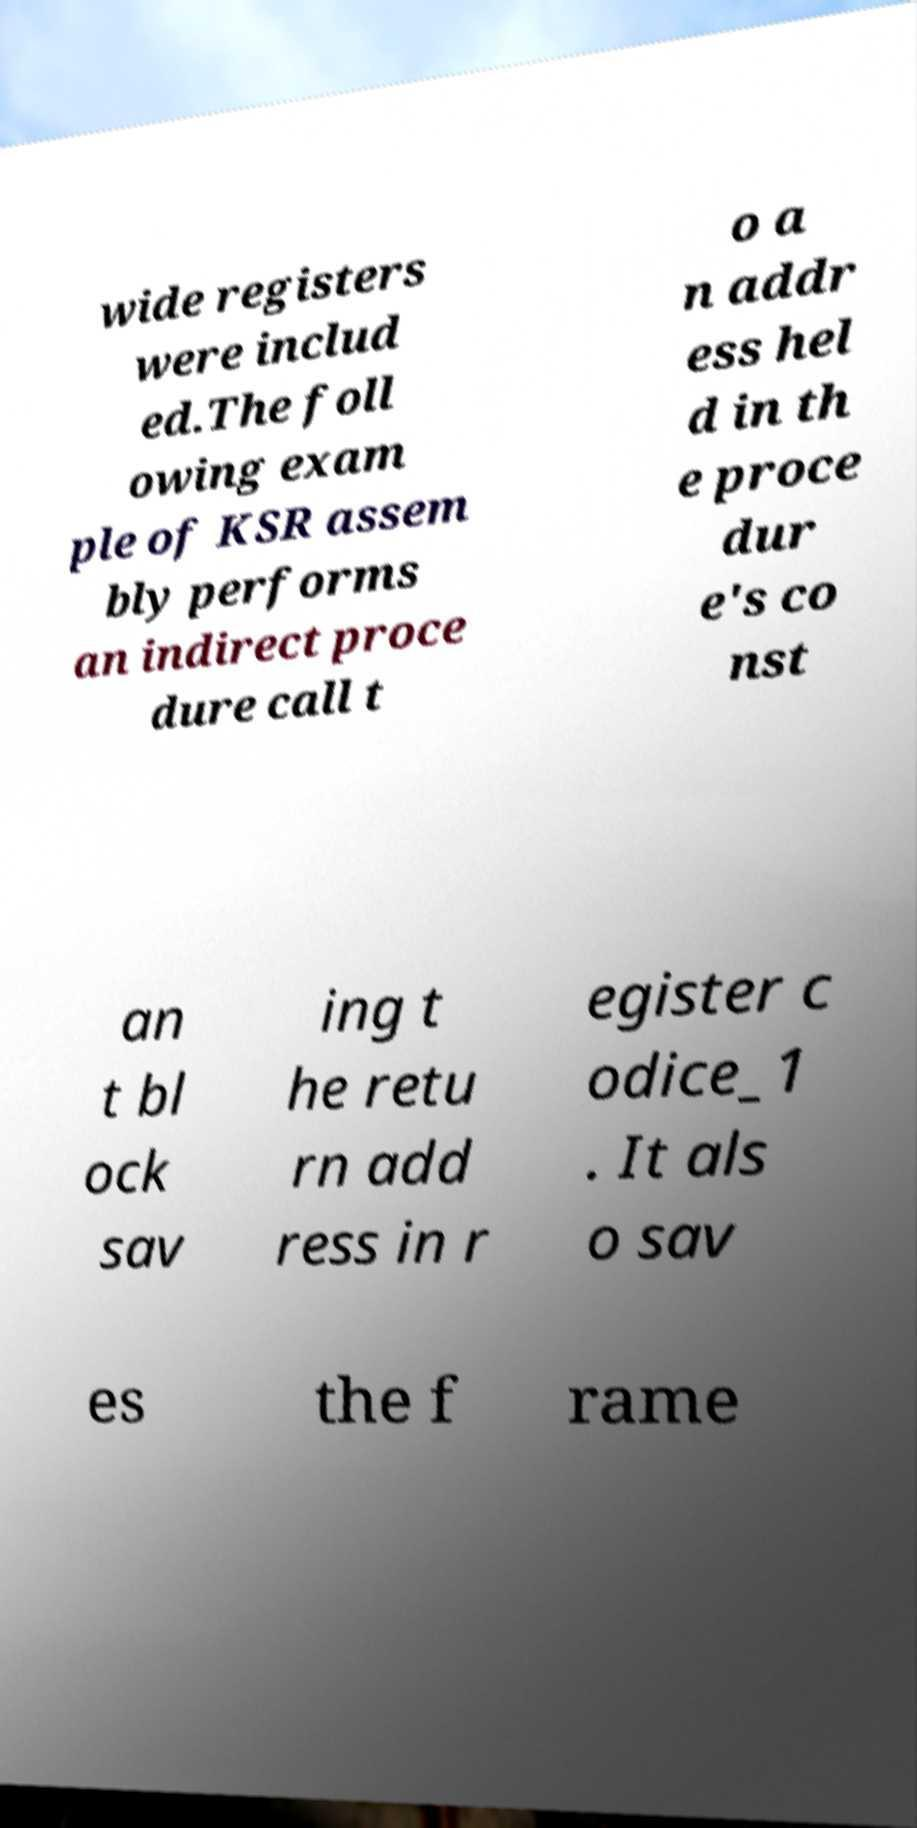What messages or text are displayed in this image? I need them in a readable, typed format. wide registers were includ ed.The foll owing exam ple of KSR assem bly performs an indirect proce dure call t o a n addr ess hel d in th e proce dur e's co nst an t bl ock sav ing t he retu rn add ress in r egister c odice_1 . It als o sav es the f rame 